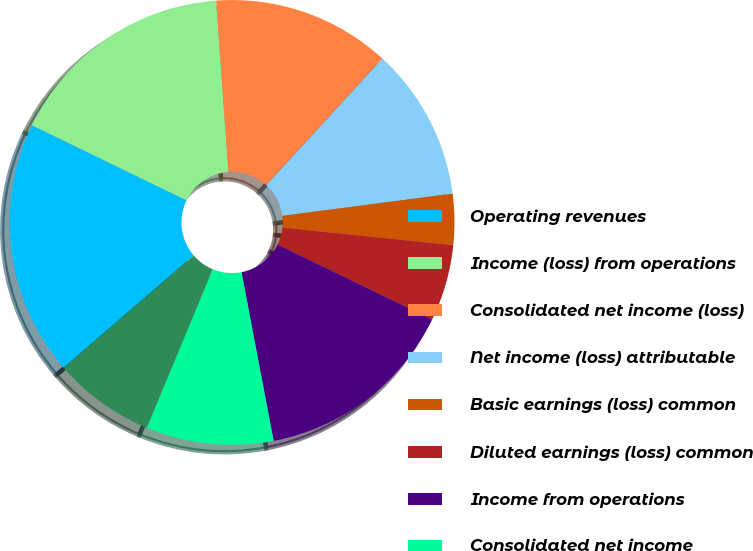<chart> <loc_0><loc_0><loc_500><loc_500><pie_chart><fcel>Operating revenues<fcel>Income (loss) from operations<fcel>Consolidated net income (loss)<fcel>Net income (loss) attributable<fcel>Basic earnings (loss) common<fcel>Diluted earnings (loss) common<fcel>Income from operations<fcel>Consolidated net income<fcel>Net income attributable to<fcel>Basic earnings per common<nl><fcel>18.52%<fcel>16.67%<fcel>12.96%<fcel>11.11%<fcel>3.71%<fcel>5.56%<fcel>14.81%<fcel>9.26%<fcel>7.41%<fcel>0.0%<nl></chart> 